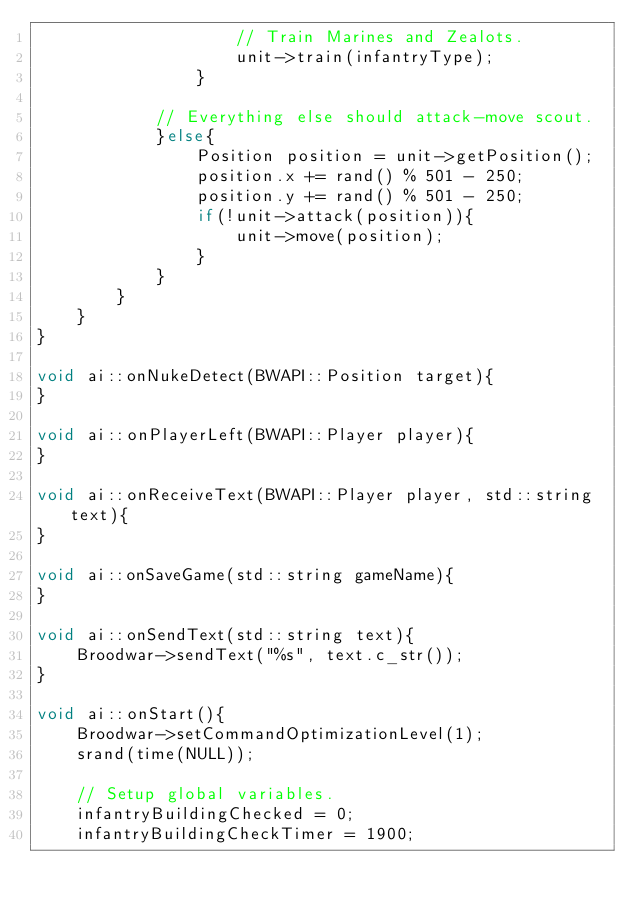<code> <loc_0><loc_0><loc_500><loc_500><_C++_>                    // Train Marines and Zealots.
                    unit->train(infantryType);
                }

            // Everything else should attack-move scout.
            }else{
                Position position = unit->getPosition();
                position.x += rand() % 501 - 250;
                position.y += rand() % 501 - 250;
                if(!unit->attack(position)){
                    unit->move(position);
                }
            }
        }
    }
}

void ai::onNukeDetect(BWAPI::Position target){
}

void ai::onPlayerLeft(BWAPI::Player player){
}

void ai::onReceiveText(BWAPI::Player player, std::string text){
}

void ai::onSaveGame(std::string gameName){
}

void ai::onSendText(std::string text){
    Broodwar->sendText("%s", text.c_str());
}

void ai::onStart(){
    Broodwar->setCommandOptimizationLevel(1);
    srand(time(NULL));

    // Setup global variables.
    infantryBuildingChecked = 0;
    infantryBuildingCheckTimer = 1900;</code> 